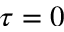<formula> <loc_0><loc_0><loc_500><loc_500>\tau = 0</formula> 